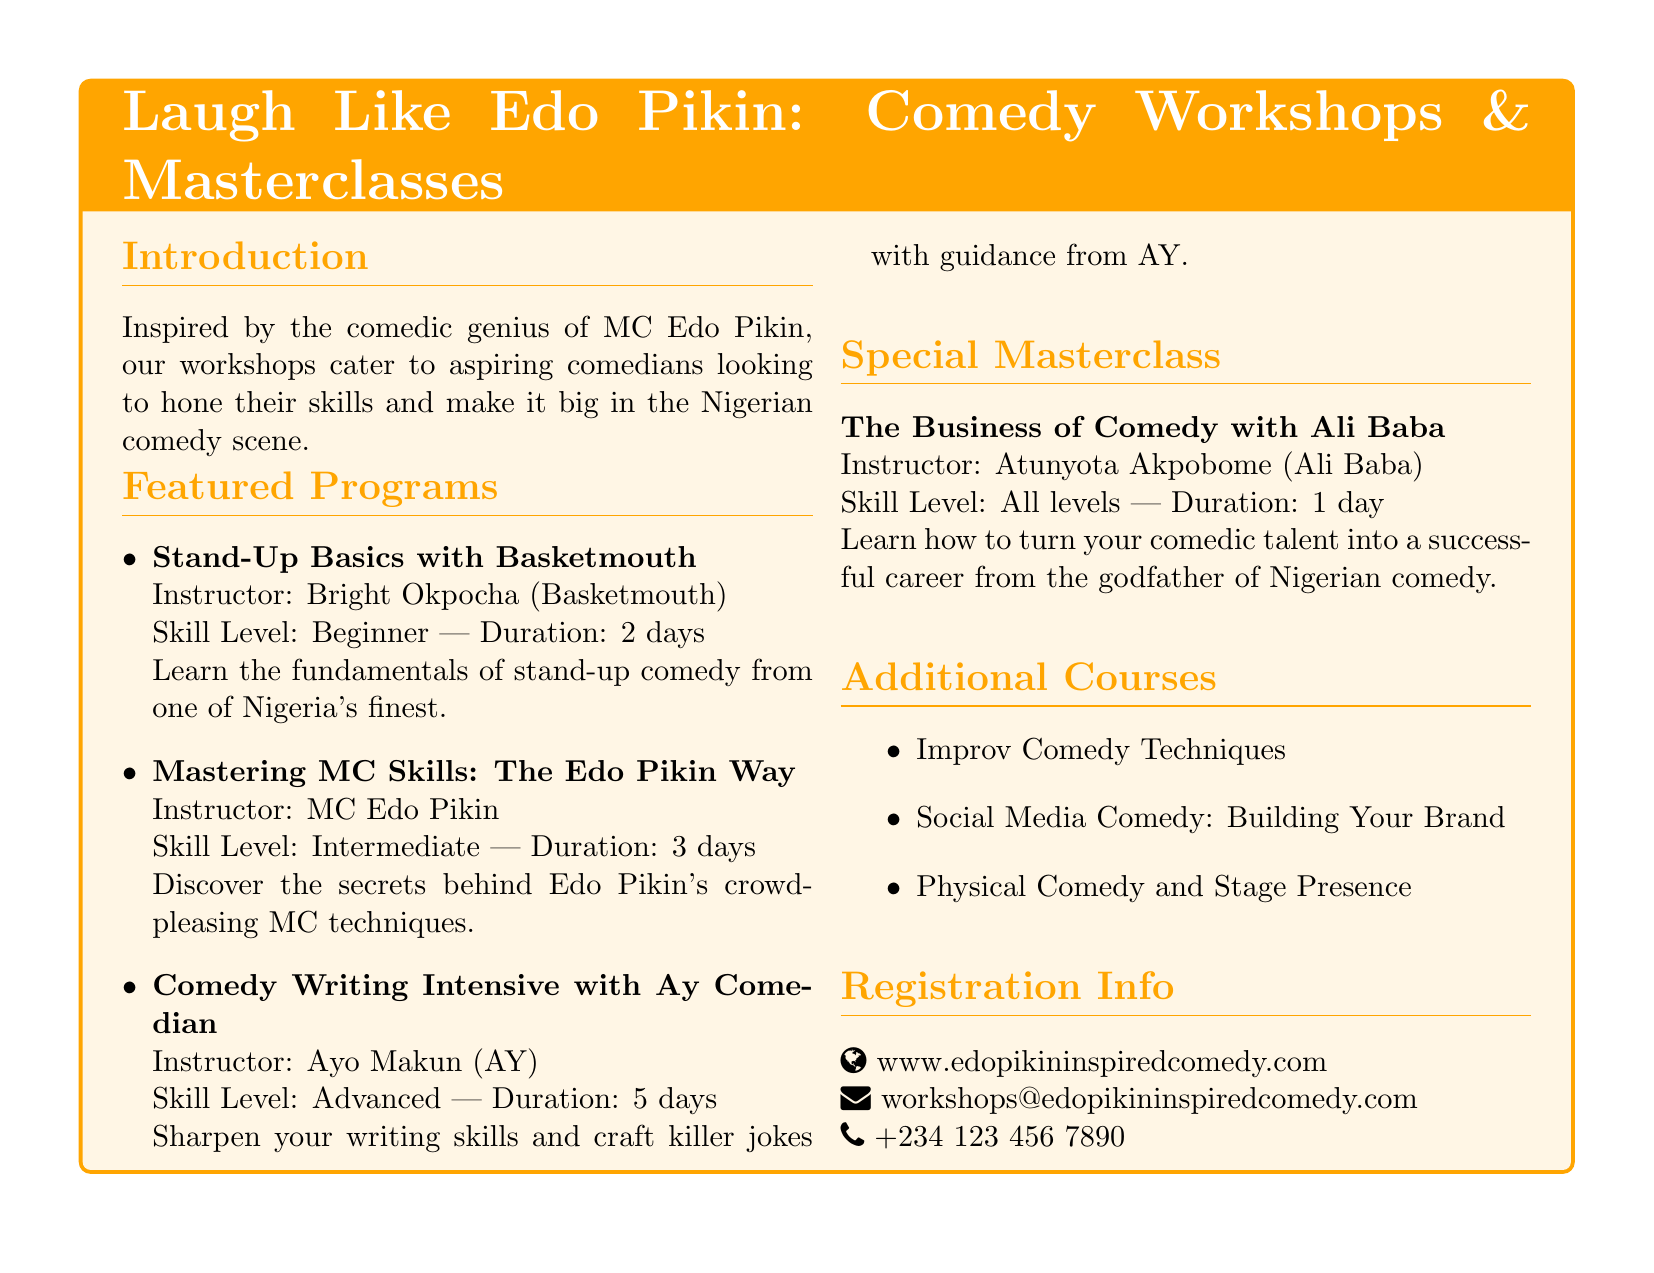What is the title of the workshop? The title is found in the tcolorbox section, which introduces the workshops.
Answer: Laugh Like Edo Pikin: Comedy Workshops & Masterclasses Who is the instructor for the "Stand-Up Basics" workshop? The instructor's name is mentioned next to the workshop title in the featured programs section.
Answer: Bright Okpocha (Basketmouth) What is the skill level required for the "Comedy Writing Intensive"? The skill level is specified in the featured programs section next to the workshop title.
Answer: Advanced How long does the "The Business of Comedy" masterclass last? The duration is indicated next to the skill level in the special masterclass section.
Answer: 1 day What type of comedy techniques are taught in the additional courses? The types of courses are listed under the additional courses section at the end of the document.
Answer: Improv Comedy Techniques What email should be used for workshop registration inquiries? The email is provided in the registration info section of the document.
Answer: workshops@edopikininspiredcomedy.com How many days is the "Mastering MC Skills" workshop? The number of days is stated next to the skill level in the featured programs section.
Answer: 3 days Which instructor is referred to as the "godfather of Nigerian comedy"? The description in the special masterclass section identifies this person.
Answer: Atunyota Akpobome (Ali Baba) 